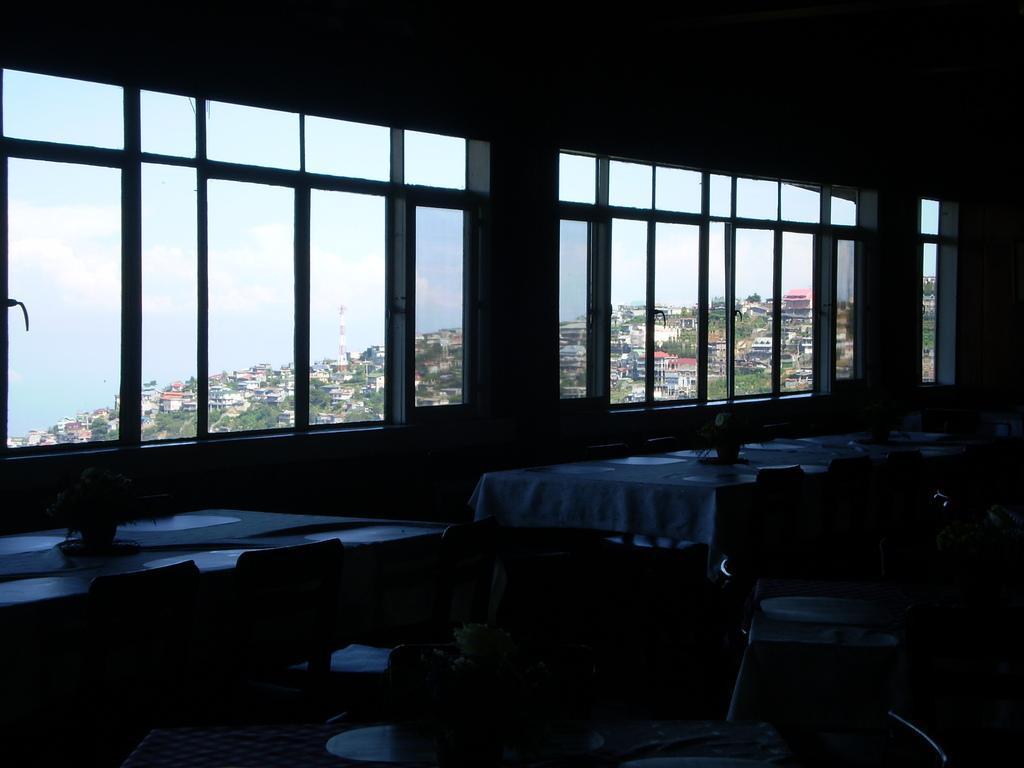Can you describe this image briefly? In this image I can see a tables and chairs. We can see some objects on the table. Back Side I can see glass windows,trees and buildings. The sky is in blue and white color. 